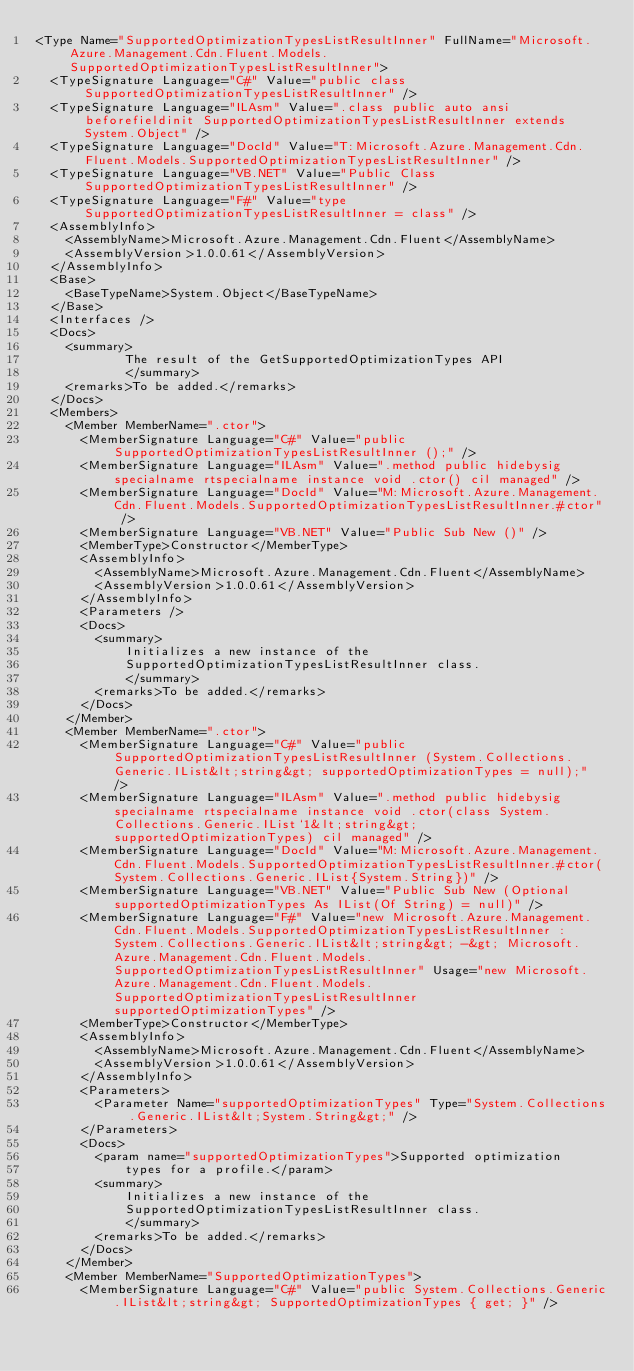<code> <loc_0><loc_0><loc_500><loc_500><_XML_><Type Name="SupportedOptimizationTypesListResultInner" FullName="Microsoft.Azure.Management.Cdn.Fluent.Models.SupportedOptimizationTypesListResultInner">
  <TypeSignature Language="C#" Value="public class SupportedOptimizationTypesListResultInner" />
  <TypeSignature Language="ILAsm" Value=".class public auto ansi beforefieldinit SupportedOptimizationTypesListResultInner extends System.Object" />
  <TypeSignature Language="DocId" Value="T:Microsoft.Azure.Management.Cdn.Fluent.Models.SupportedOptimizationTypesListResultInner" />
  <TypeSignature Language="VB.NET" Value="Public Class SupportedOptimizationTypesListResultInner" />
  <TypeSignature Language="F#" Value="type SupportedOptimizationTypesListResultInner = class" />
  <AssemblyInfo>
    <AssemblyName>Microsoft.Azure.Management.Cdn.Fluent</AssemblyName>
    <AssemblyVersion>1.0.0.61</AssemblyVersion>
  </AssemblyInfo>
  <Base>
    <BaseTypeName>System.Object</BaseTypeName>
  </Base>
  <Interfaces />
  <Docs>
    <summary>
            The result of the GetSupportedOptimizationTypes API
            </summary>
    <remarks>To be added.</remarks>
  </Docs>
  <Members>
    <Member MemberName=".ctor">
      <MemberSignature Language="C#" Value="public SupportedOptimizationTypesListResultInner ();" />
      <MemberSignature Language="ILAsm" Value=".method public hidebysig specialname rtspecialname instance void .ctor() cil managed" />
      <MemberSignature Language="DocId" Value="M:Microsoft.Azure.Management.Cdn.Fluent.Models.SupportedOptimizationTypesListResultInner.#ctor" />
      <MemberSignature Language="VB.NET" Value="Public Sub New ()" />
      <MemberType>Constructor</MemberType>
      <AssemblyInfo>
        <AssemblyName>Microsoft.Azure.Management.Cdn.Fluent</AssemblyName>
        <AssemblyVersion>1.0.0.61</AssemblyVersion>
      </AssemblyInfo>
      <Parameters />
      <Docs>
        <summary>
            Initializes a new instance of the
            SupportedOptimizationTypesListResultInner class.
            </summary>
        <remarks>To be added.</remarks>
      </Docs>
    </Member>
    <Member MemberName=".ctor">
      <MemberSignature Language="C#" Value="public SupportedOptimizationTypesListResultInner (System.Collections.Generic.IList&lt;string&gt; supportedOptimizationTypes = null);" />
      <MemberSignature Language="ILAsm" Value=".method public hidebysig specialname rtspecialname instance void .ctor(class System.Collections.Generic.IList`1&lt;string&gt; supportedOptimizationTypes) cil managed" />
      <MemberSignature Language="DocId" Value="M:Microsoft.Azure.Management.Cdn.Fluent.Models.SupportedOptimizationTypesListResultInner.#ctor(System.Collections.Generic.IList{System.String})" />
      <MemberSignature Language="VB.NET" Value="Public Sub New (Optional supportedOptimizationTypes As IList(Of String) = null)" />
      <MemberSignature Language="F#" Value="new Microsoft.Azure.Management.Cdn.Fluent.Models.SupportedOptimizationTypesListResultInner : System.Collections.Generic.IList&lt;string&gt; -&gt; Microsoft.Azure.Management.Cdn.Fluent.Models.SupportedOptimizationTypesListResultInner" Usage="new Microsoft.Azure.Management.Cdn.Fluent.Models.SupportedOptimizationTypesListResultInner supportedOptimizationTypes" />
      <MemberType>Constructor</MemberType>
      <AssemblyInfo>
        <AssemblyName>Microsoft.Azure.Management.Cdn.Fluent</AssemblyName>
        <AssemblyVersion>1.0.0.61</AssemblyVersion>
      </AssemblyInfo>
      <Parameters>
        <Parameter Name="supportedOptimizationTypes" Type="System.Collections.Generic.IList&lt;System.String&gt;" />
      </Parameters>
      <Docs>
        <param name="supportedOptimizationTypes">Supported optimization
            types for a profile.</param>
        <summary>
            Initializes a new instance of the
            SupportedOptimizationTypesListResultInner class.
            </summary>
        <remarks>To be added.</remarks>
      </Docs>
    </Member>
    <Member MemberName="SupportedOptimizationTypes">
      <MemberSignature Language="C#" Value="public System.Collections.Generic.IList&lt;string&gt; SupportedOptimizationTypes { get; }" /></code> 